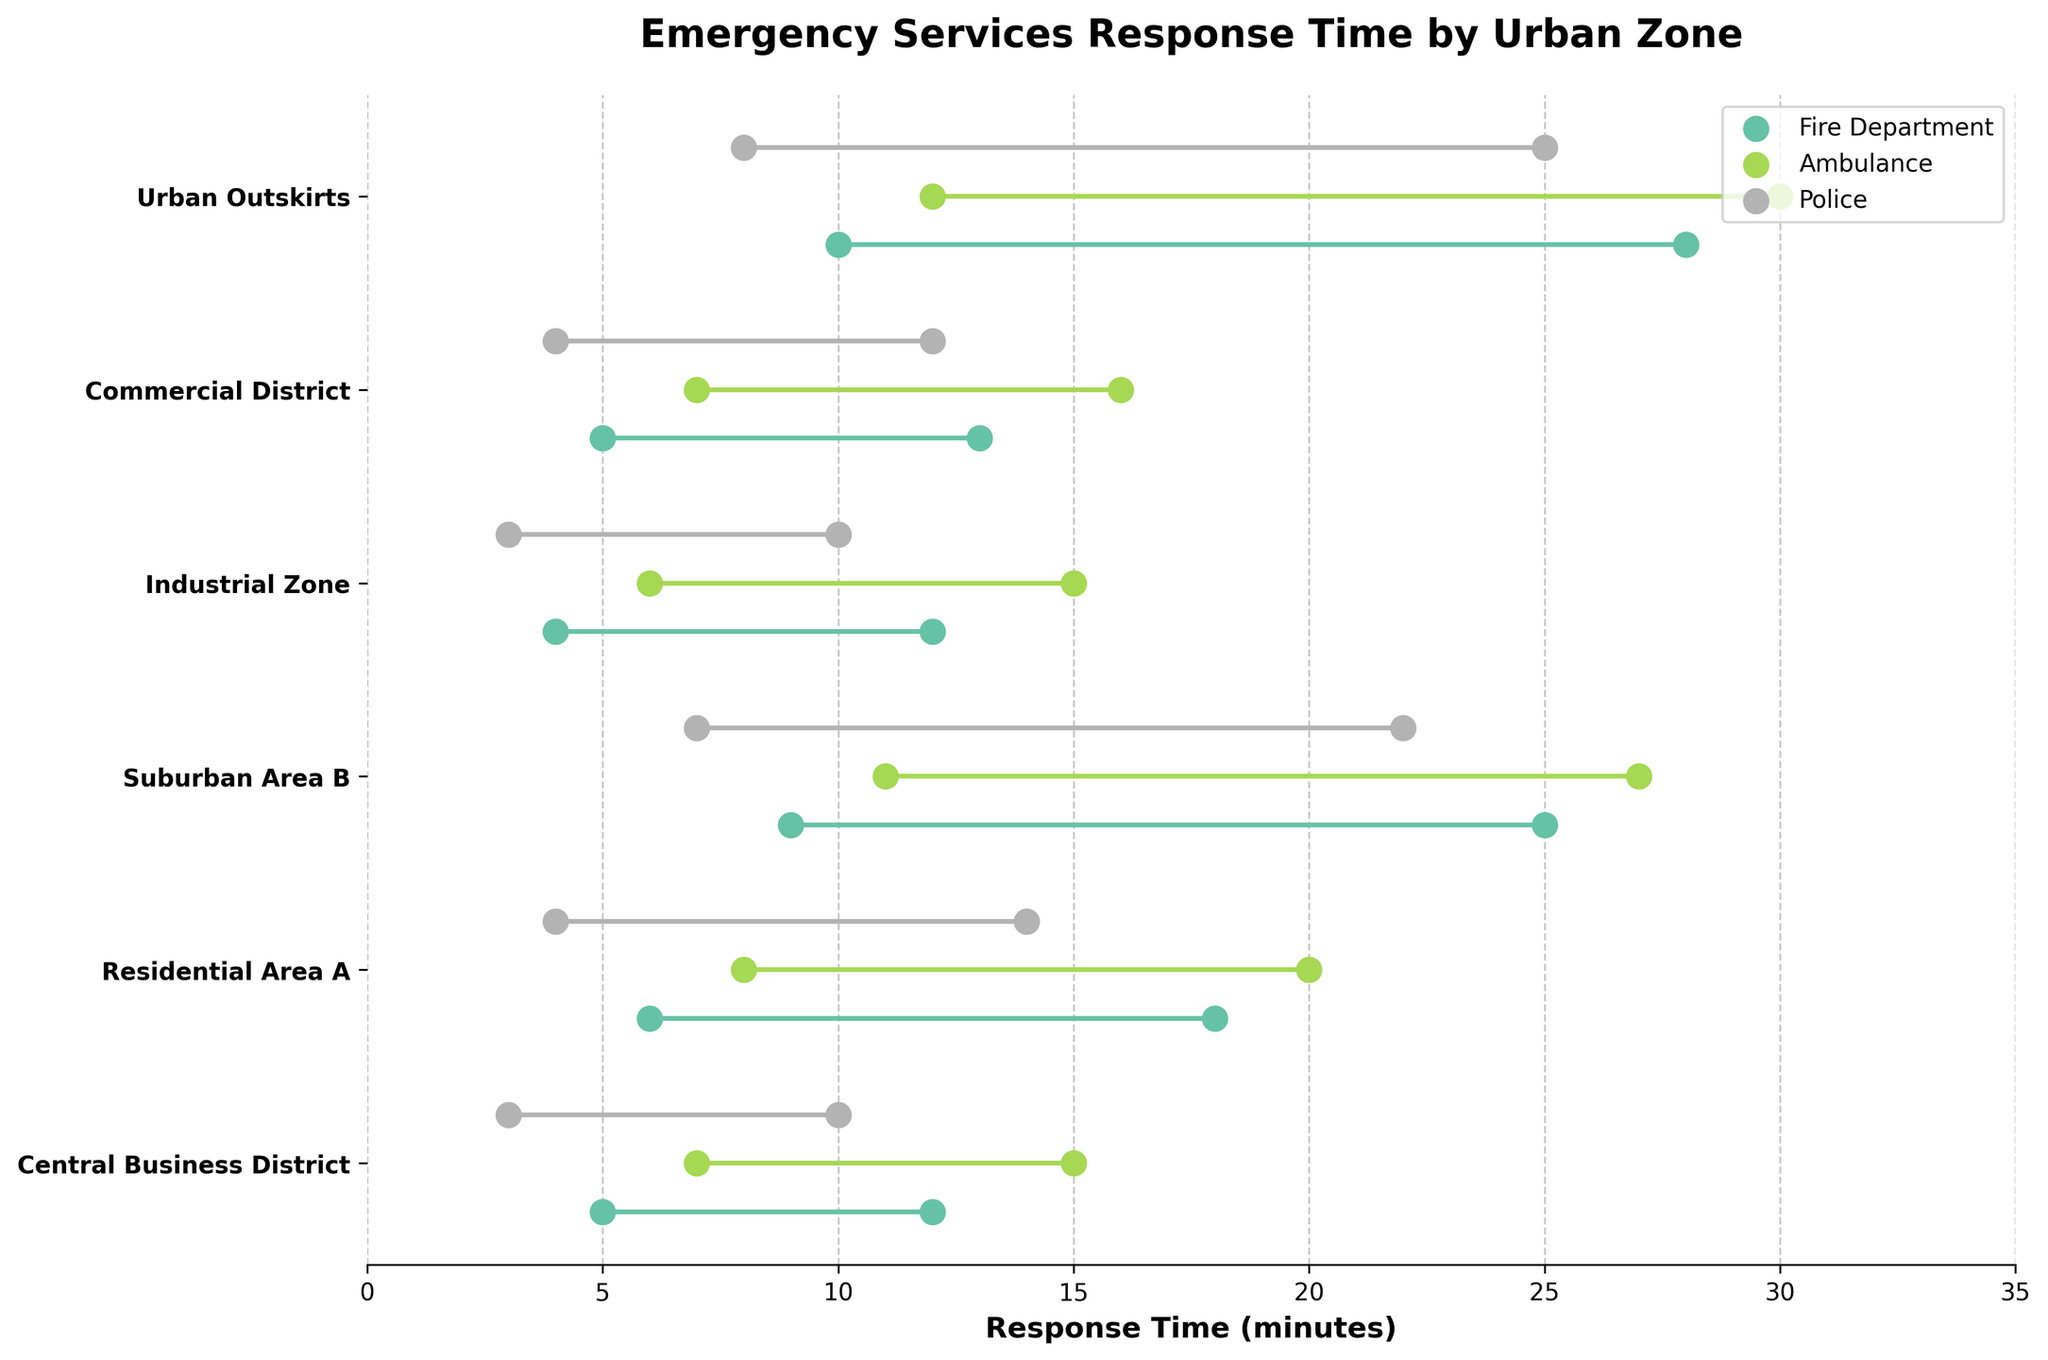What's the title of the plot? The plot's title can typically be found at the top. In this plot, the title is displayed in bold and large font.
Answer: Emergency Services Response Time by Urban Zone What is the minimum response time for the Police in the Central Business District? Refer to the plotted points corresponding to the Police in the Central Business District. The leftmost point represents the minimum response time.
Answer: 3 minutes Which urban zone has the longest maximum response time for the Ambulance service? By examining each plotted point for Ambulance services across all zones, identify the zone with the rightmost point.
Answer: Urban Outskirts Compare the response times of Fire Department and Police in Residential Area A. Which one has a shorter maximum response time? Look at the highest response points for both the Fire Department and Police in Residential Area A and compare them.
Answer: Police What is the range of response times for the Ambulance in Suburban Area B? Locate the minimum and maximum response times for the Ambulance in Suburban Area B. The range is the difference between these two values.
Answer: 16 minutes Which emergency service consistently has the shortest minimum response time across all urban zones? Review the minimum response times for all services across all zones. Identify the service with the smallest minimum response times.
Answer: Police Which urban zone has the smallest range in response times for all emergency services? For each urban zone, calculate the difference between the maximum and minimum response times for all services and compare.
Answer: Central Business District or Industrial Zone (both have small ranges) What is the difference in maximum response time between the Fire Department in the Commercial District and Urban Outskirts? Compare the rightmost points for the Fire Department in both the Commercial District and Urban Outskirts. Subtract the smaller value from the larger one.
Answer: 15 minutes (28 - 13) Which urban zone has the widest range in response times for the Fire Department? Calculate the range (max - min) for Fire Department response times across all zones and identify the one with the largest value.
Answer: Urban Outskirts 